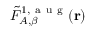Convert formula to latex. <formula><loc_0><loc_0><loc_500><loc_500>\tilde { F } _ { A , \beta } ^ { 1 , a u g } ( r )</formula> 